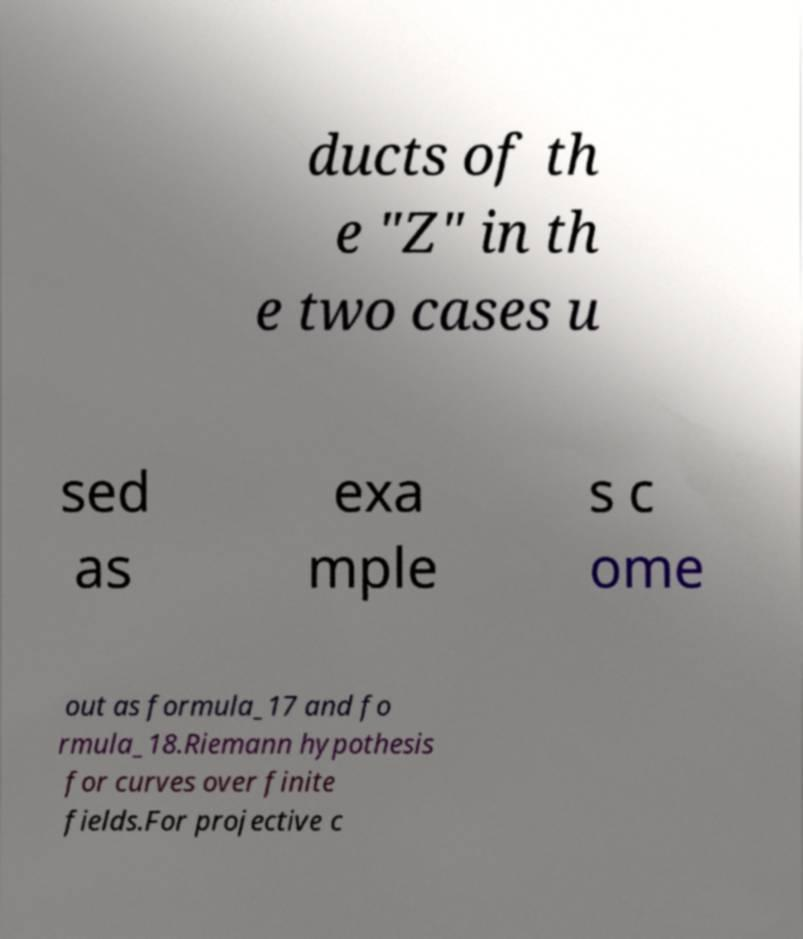Can you accurately transcribe the text from the provided image for me? ducts of th e "Z" in th e two cases u sed as exa mple s c ome out as formula_17 and fo rmula_18.Riemann hypothesis for curves over finite fields.For projective c 